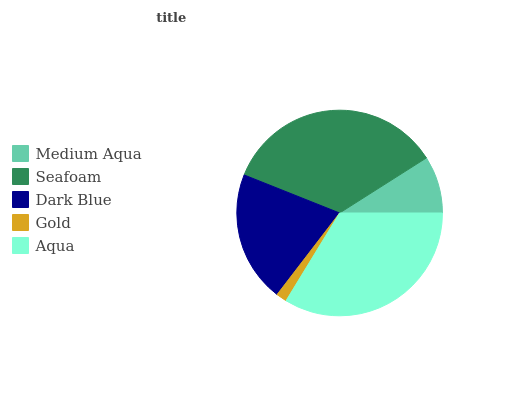Is Gold the minimum?
Answer yes or no. Yes. Is Seafoam the maximum?
Answer yes or no. Yes. Is Dark Blue the minimum?
Answer yes or no. No. Is Dark Blue the maximum?
Answer yes or no. No. Is Seafoam greater than Dark Blue?
Answer yes or no. Yes. Is Dark Blue less than Seafoam?
Answer yes or no. Yes. Is Dark Blue greater than Seafoam?
Answer yes or no. No. Is Seafoam less than Dark Blue?
Answer yes or no. No. Is Dark Blue the high median?
Answer yes or no. Yes. Is Dark Blue the low median?
Answer yes or no. Yes. Is Seafoam the high median?
Answer yes or no. No. Is Medium Aqua the low median?
Answer yes or no. No. 